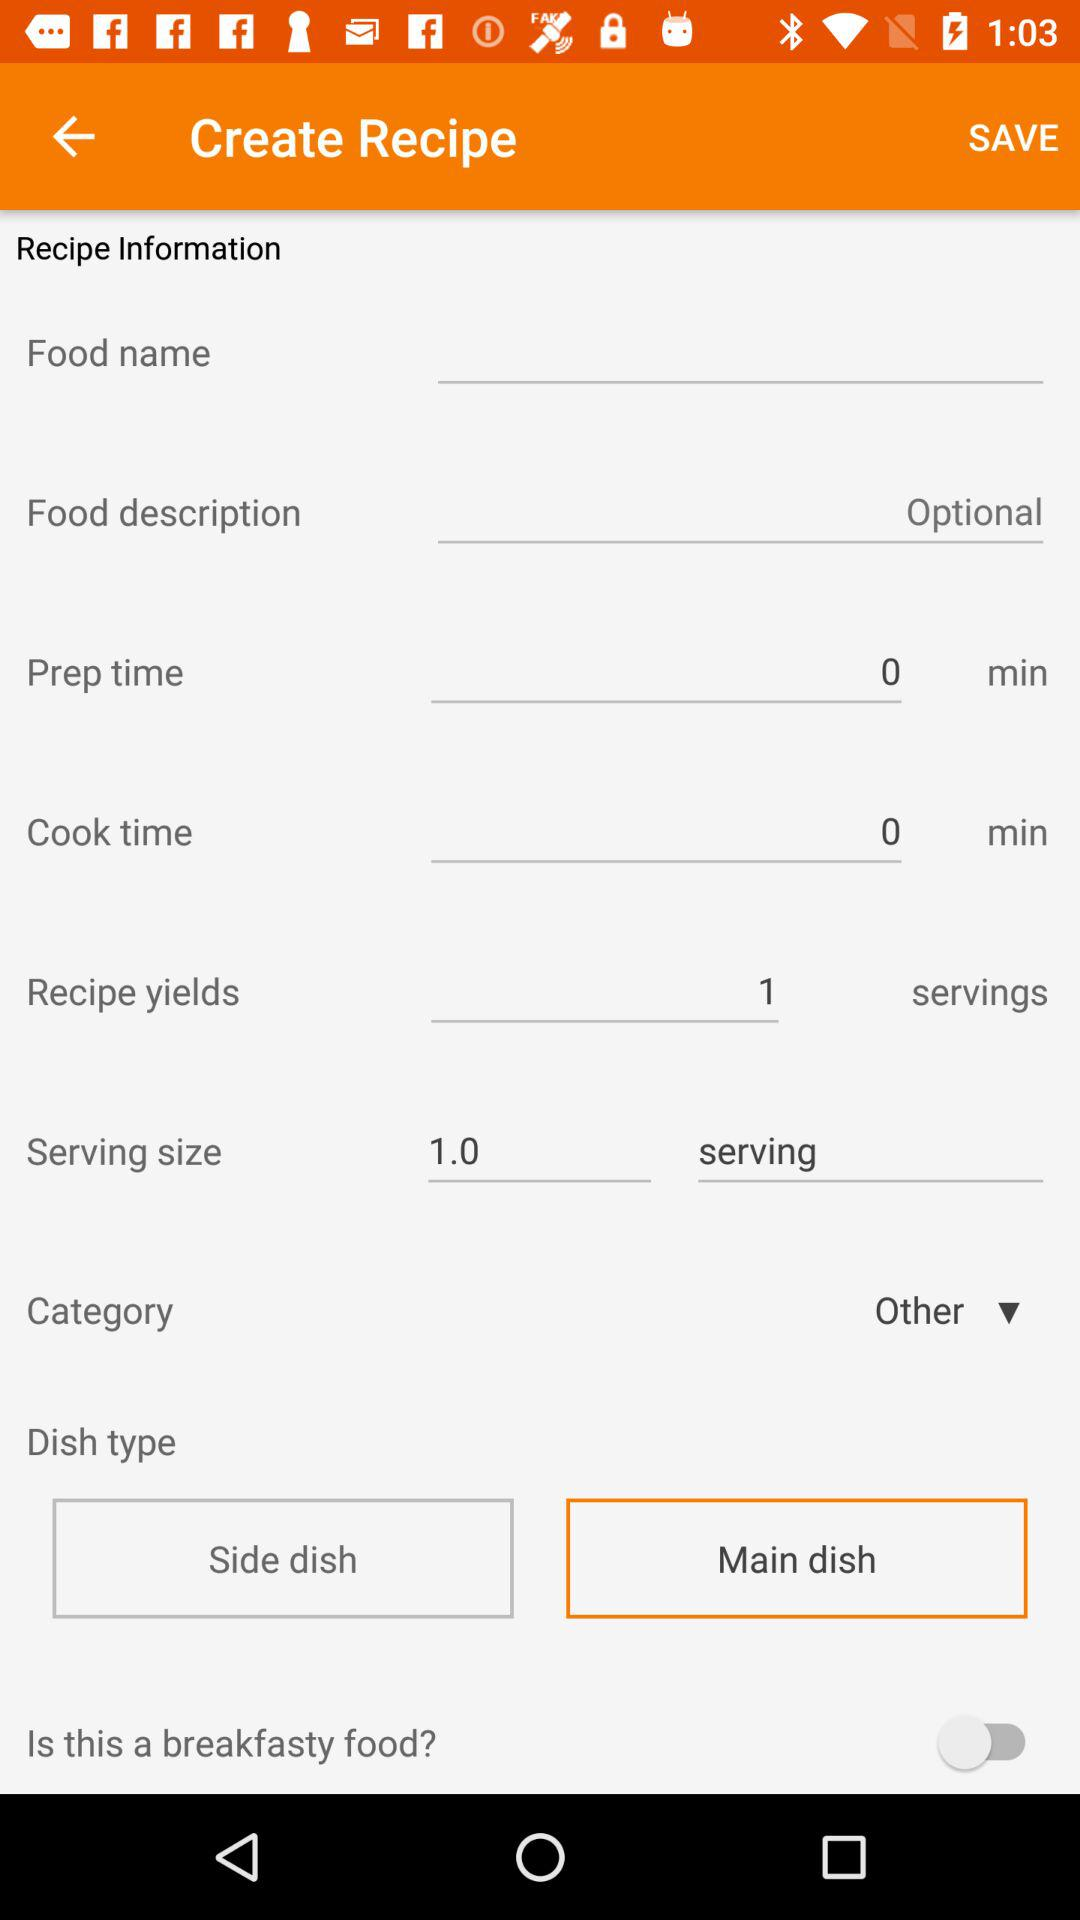How many more minutes does the cook time take than the prep time?
Answer the question using a single word or phrase. 0 